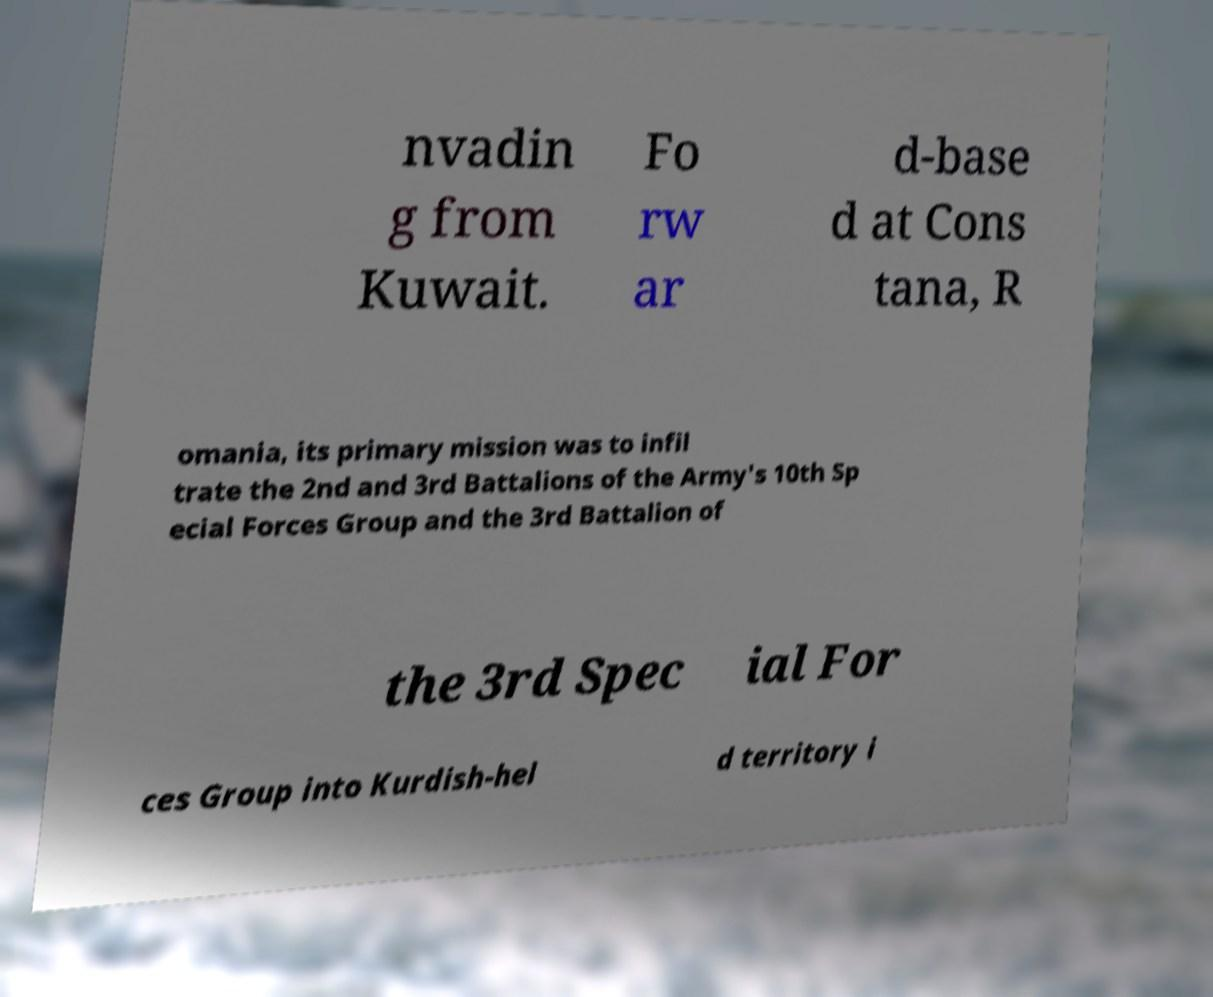Can you accurately transcribe the text from the provided image for me? nvadin g from Kuwait. Fo rw ar d-base d at Cons tana, R omania, its primary mission was to infil trate the 2nd and 3rd Battalions of the Army's 10th Sp ecial Forces Group and the 3rd Battalion of the 3rd Spec ial For ces Group into Kurdish-hel d territory i 